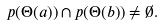Convert formula to latex. <formula><loc_0><loc_0><loc_500><loc_500>p ( \Theta ( a ) ) \cap p ( \Theta ( b ) ) \neq \emptyset .</formula> 